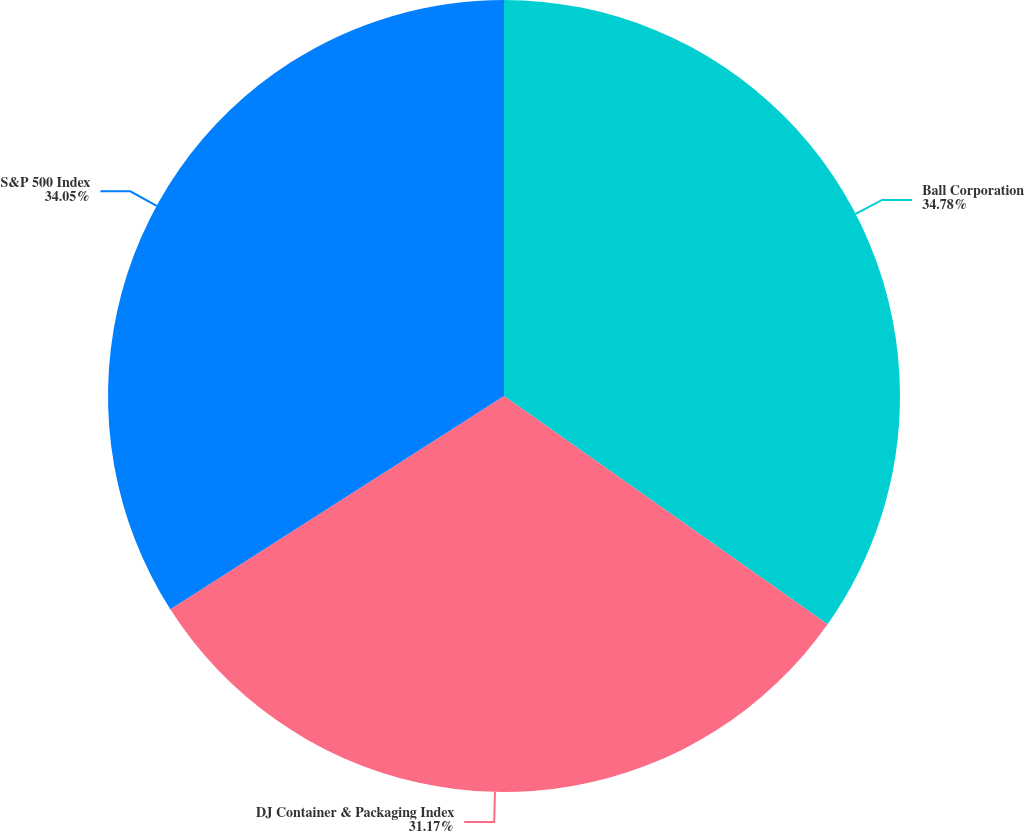<chart> <loc_0><loc_0><loc_500><loc_500><pie_chart><fcel>Ball Corporation<fcel>DJ Container & Packaging Index<fcel>S&P 500 Index<nl><fcel>34.78%<fcel>31.17%<fcel>34.05%<nl></chart> 